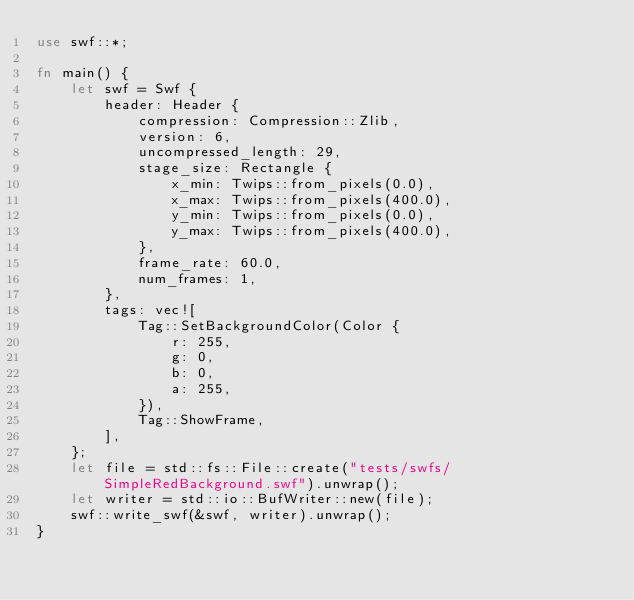<code> <loc_0><loc_0><loc_500><loc_500><_Rust_>use swf::*;

fn main() {
    let swf = Swf {
        header: Header {
            compression: Compression::Zlib,
            version: 6,
            uncompressed_length: 29,
            stage_size: Rectangle {
                x_min: Twips::from_pixels(0.0),
                x_max: Twips::from_pixels(400.0),
                y_min: Twips::from_pixels(0.0),
                y_max: Twips::from_pixels(400.0),
            },
            frame_rate: 60.0,
            num_frames: 1,
        },
        tags: vec![
            Tag::SetBackgroundColor(Color {
                r: 255,
                g: 0,
                b: 0,
                a: 255,
            }),
            Tag::ShowFrame,
        ],
    };
    let file = std::fs::File::create("tests/swfs/SimpleRedBackground.swf").unwrap();
    let writer = std::io::BufWriter::new(file);
    swf::write_swf(&swf, writer).unwrap();
}
</code> 